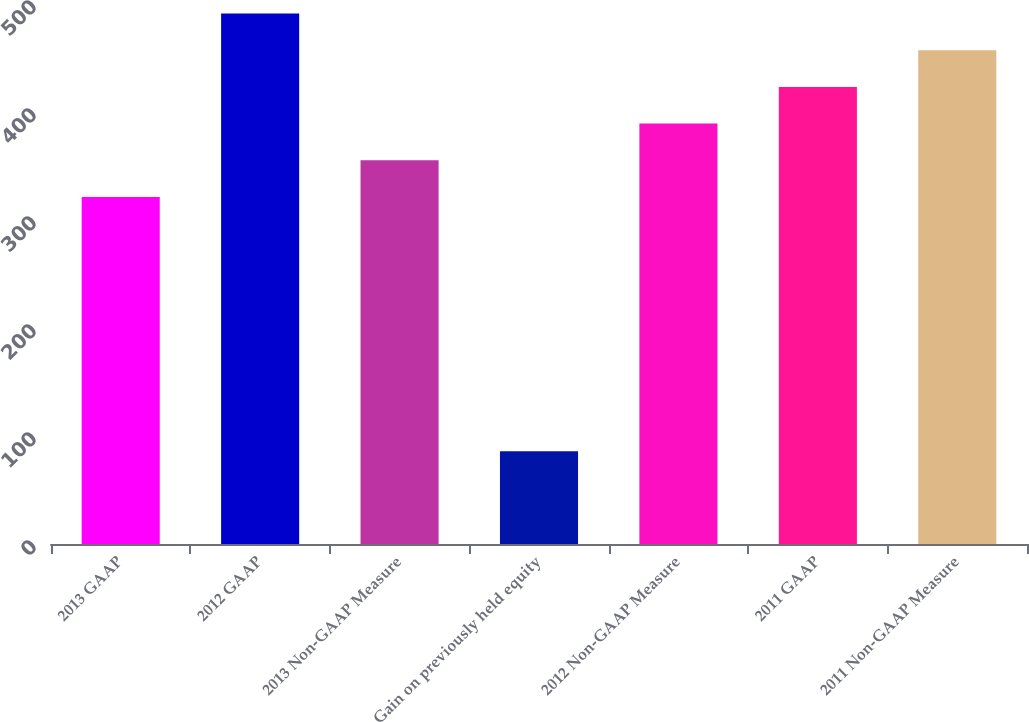<chart> <loc_0><loc_0><loc_500><loc_500><bar_chart><fcel>2013 GAAP<fcel>2012 GAAP<fcel>2013 Non-GAAP Measure<fcel>Gain on previously held equity<fcel>2012 Non-GAAP Measure<fcel>2011 GAAP<fcel>2011 Non-GAAP Measure<nl><fcel>321.3<fcel>491.15<fcel>355.27<fcel>85.9<fcel>389.24<fcel>423.21<fcel>457.18<nl></chart> 